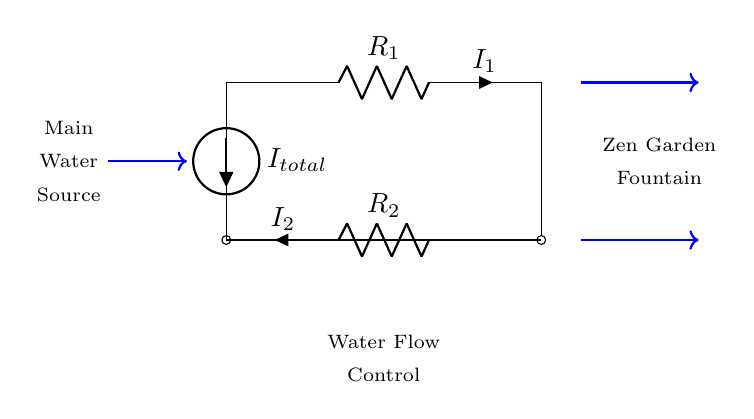What is the total current entering the circuit? The diagram shows an American current source labeled as I_total, indicating the total current entering the circuit. Therefore, the answer is simply the value noted beside the source.
Answer: I_total What are the components used in the circuit? The circuit includes two resistors labeled R_1 and R_2, and an American current source, so these are the main components present in the circuit.
Answer: R_1, R_2, I_total How many branches are present in this circuit? The circuit graphs two primary branches originating from the same source (I_total) which divides into R_1 and R_2, indicating two distinct paths for current flow.
Answer: 2 What does each resistor control in the circuit? R_1 and R_2 control the flow of current I_1 and I_2 respectively, acting to divide the total current (I_total) based on their resistances, showing the relationship between current and resistance.
Answer: I_1 and I_2 If the resistance R_1 is increased, what happens to I_1? According to Ohm's Law, increasing R_1 will decrease the current I_1 flowing through it, as total current I_total remains fixed but divides differently among R_1 and R_2.
Answer: Decreases What is the purpose of this circuit? The circuit's purpose is to control the flow of water in a zen garden fountain by managing the division of current (which can represent flow) through the two resistors into two different pathways.
Answer: Water flow control How are the resistances R_1 and R_2 determined? The values of R_1 and R_2 are chosen based on the desired division of current for the specific application, which is indicated here by the resistance labeled next to each resistor based on the design criteria for the zen fountain.
Answer: Based on design criteria 